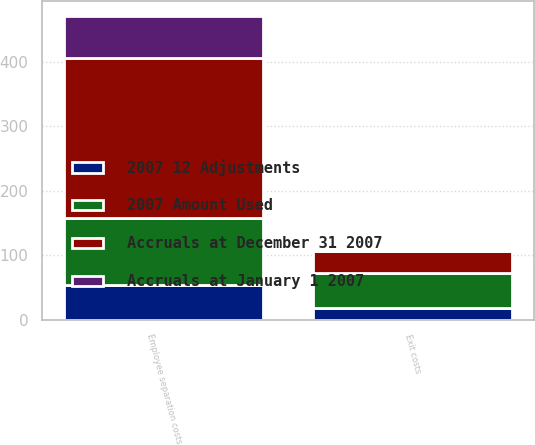Convert chart. <chart><loc_0><loc_0><loc_500><loc_500><stacked_bar_chart><ecel><fcel>Exit costs<fcel>Employee separation costs<nl><fcel>2007 Amount Used<fcel>54<fcel>104<nl><fcel>2007 12 Adjustments<fcel>19<fcel>54<nl><fcel>Accruals at January 1 2007<fcel>2<fcel>64<nl><fcel>Accruals at December 31 2007<fcel>33<fcel>248<nl></chart> 